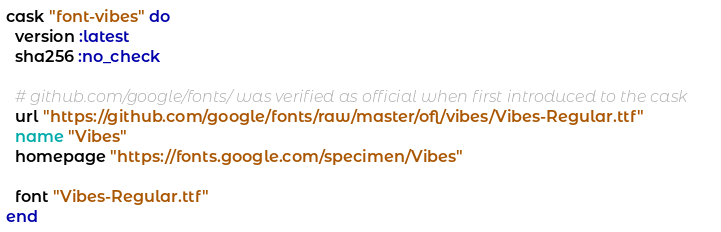<code> <loc_0><loc_0><loc_500><loc_500><_Ruby_>cask "font-vibes" do
  version :latest
  sha256 :no_check

  # github.com/google/fonts/ was verified as official when first introduced to the cask
  url "https://github.com/google/fonts/raw/master/ofl/vibes/Vibes-Regular.ttf"
  name "Vibes"
  homepage "https://fonts.google.com/specimen/Vibes"

  font "Vibes-Regular.ttf"
end
</code> 